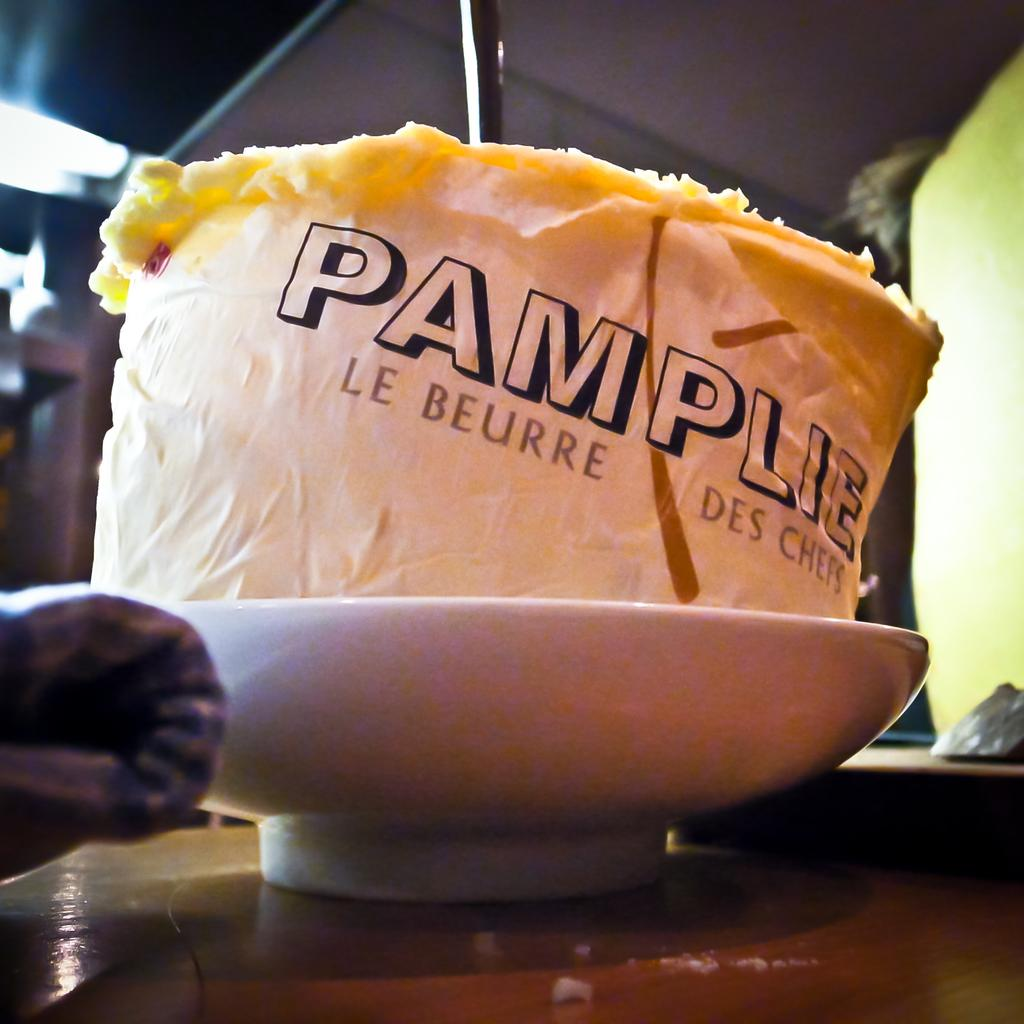What is present in the image? There is a bowl in the image. What is inside the bowl? There is something in the bowl. How many cakes are on the quiet pear in the image? There is no mention of cakes, a pear, or anything related to quietness in the image. 